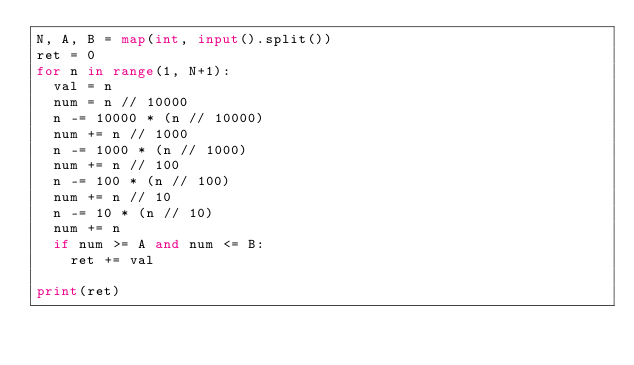<code> <loc_0><loc_0><loc_500><loc_500><_Python_>N, A, B = map(int, input().split())
ret = 0
for n in range(1, N+1):
  val = n
  num = n // 10000
  n -= 10000 * (n // 10000)
  num += n // 1000
  n -= 1000 * (n // 1000)
  num += n // 100
  n -= 100 * (n // 100)
  num += n // 10
  n -= 10 * (n // 10)
  num += n
  if num >= A and num <= B:
    ret += val

print(ret)
</code> 